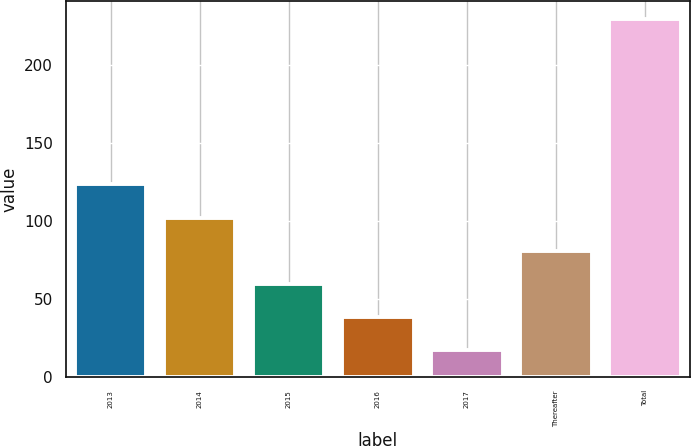<chart> <loc_0><loc_0><loc_500><loc_500><bar_chart><fcel>2013<fcel>2014<fcel>2015<fcel>2016<fcel>2017<fcel>Thereafter<fcel>Total<nl><fcel>123.5<fcel>102.24<fcel>59.72<fcel>38.46<fcel>17.2<fcel>80.98<fcel>229.8<nl></chart> 